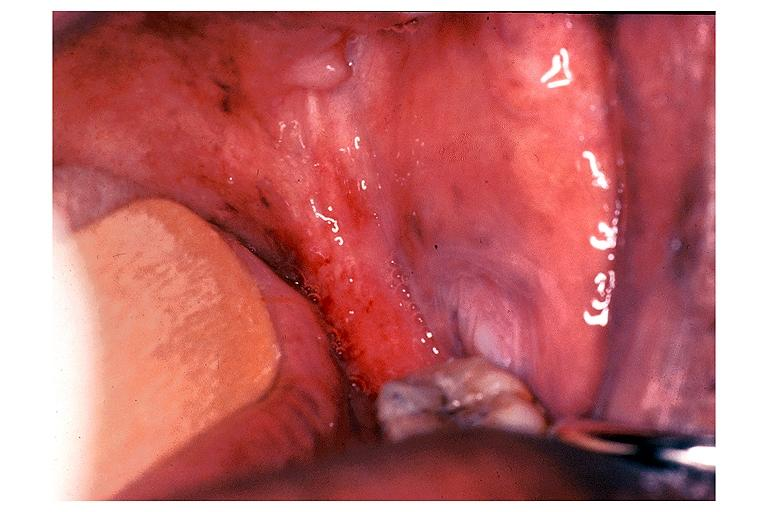does malignant histiocytosis show erythroplakia?
Answer the question using a single word or phrase. No 